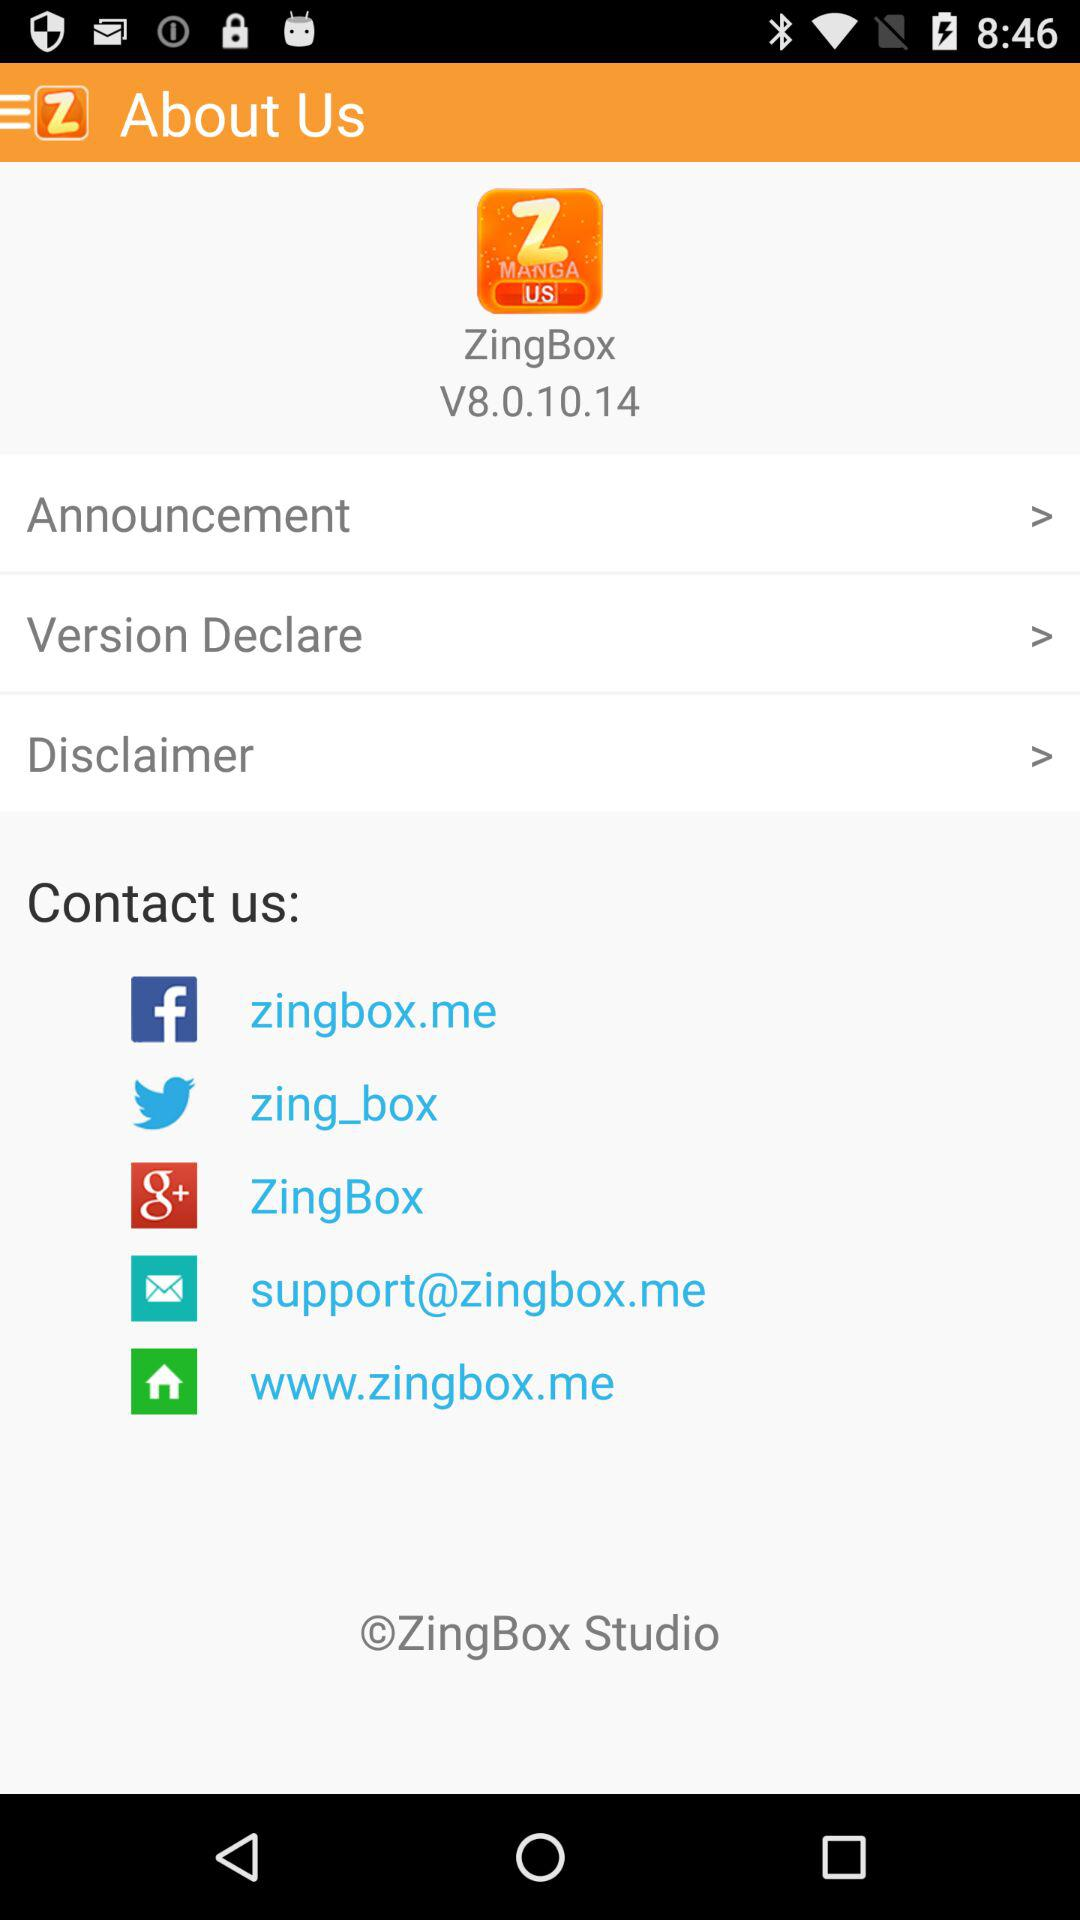What is the application name? The application name is "ZingBox". 